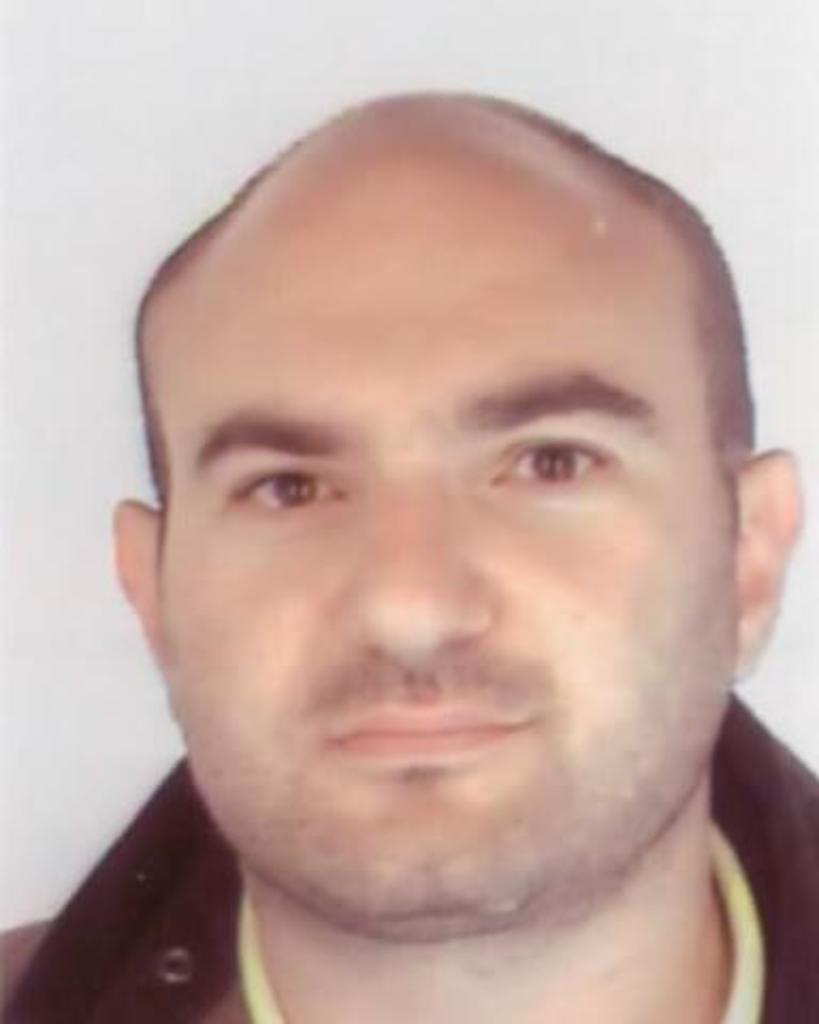How would you summarize this image in a sentence or two? In this image we can see the face of a person. 